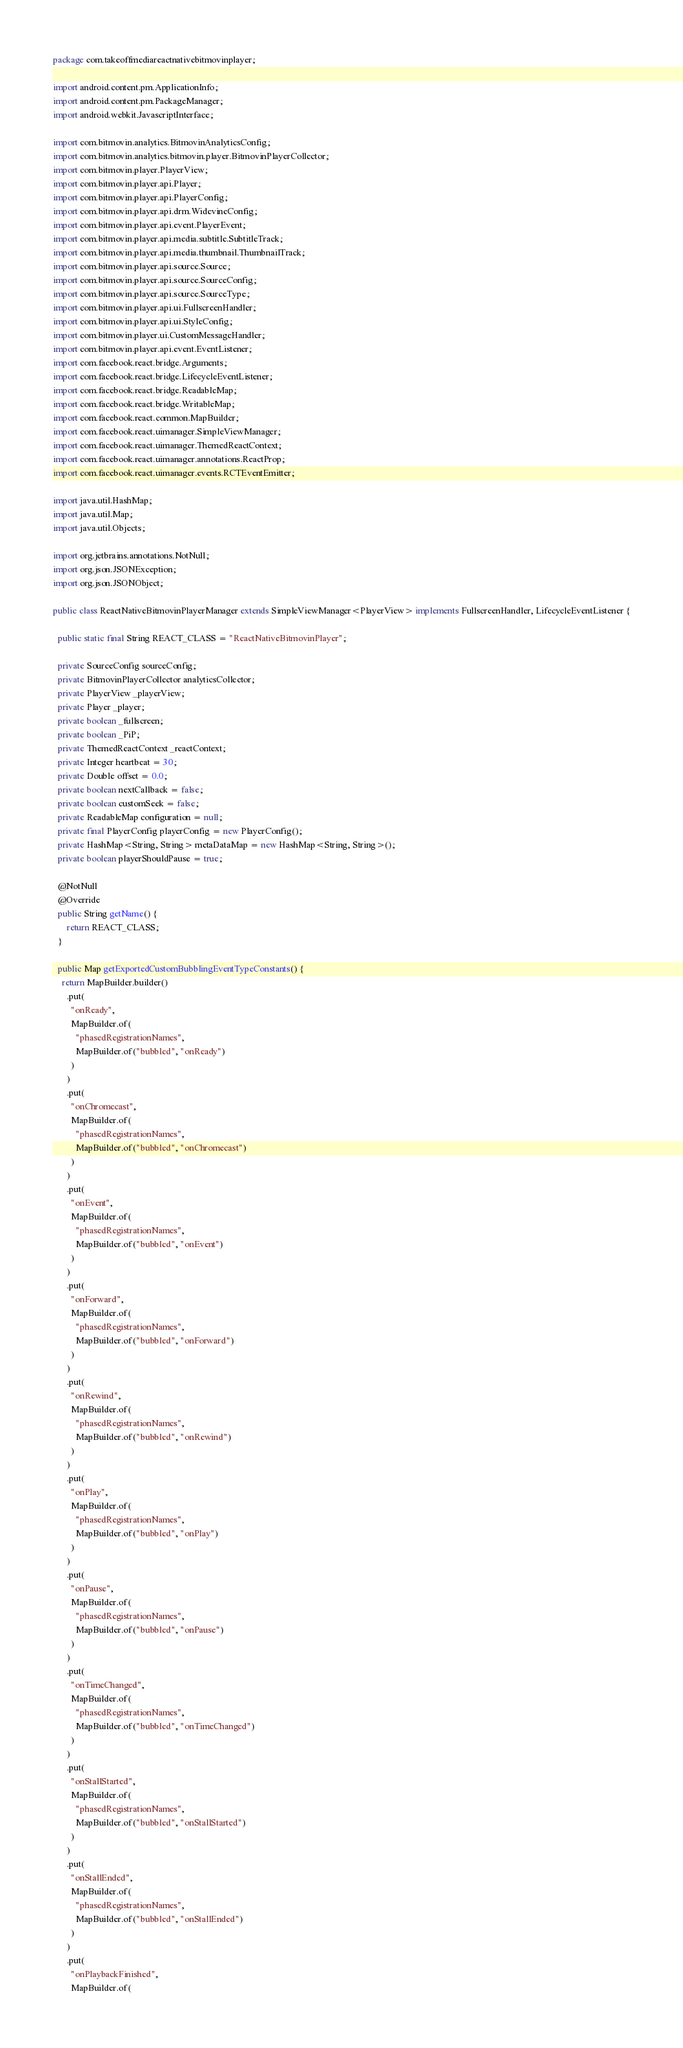Convert code to text. <code><loc_0><loc_0><loc_500><loc_500><_Java_>package com.takeoffmediareactnativebitmovinplayer;

import android.content.pm.ApplicationInfo;
import android.content.pm.PackageManager;
import android.webkit.JavascriptInterface;

import com.bitmovin.analytics.BitmovinAnalyticsConfig;
import com.bitmovin.analytics.bitmovin.player.BitmovinPlayerCollector;
import com.bitmovin.player.PlayerView;
import com.bitmovin.player.api.Player;
import com.bitmovin.player.api.PlayerConfig;
import com.bitmovin.player.api.drm.WidevineConfig;
import com.bitmovin.player.api.event.PlayerEvent;
import com.bitmovin.player.api.media.subtitle.SubtitleTrack;
import com.bitmovin.player.api.media.thumbnail.ThumbnailTrack;
import com.bitmovin.player.api.source.Source;
import com.bitmovin.player.api.source.SourceConfig;
import com.bitmovin.player.api.source.SourceType;
import com.bitmovin.player.api.ui.FullscreenHandler;
import com.bitmovin.player.api.ui.StyleConfig;
import com.bitmovin.player.ui.CustomMessageHandler;
import com.bitmovin.player.api.event.EventListener;
import com.facebook.react.bridge.Arguments;
import com.facebook.react.bridge.LifecycleEventListener;
import com.facebook.react.bridge.ReadableMap;
import com.facebook.react.bridge.WritableMap;
import com.facebook.react.common.MapBuilder;
import com.facebook.react.uimanager.SimpleViewManager;
import com.facebook.react.uimanager.ThemedReactContext;
import com.facebook.react.uimanager.annotations.ReactProp;
import com.facebook.react.uimanager.events.RCTEventEmitter;

import java.util.HashMap;
import java.util.Map;
import java.util.Objects;

import org.jetbrains.annotations.NotNull;
import org.json.JSONException;
import org.json.JSONObject;

public class ReactNativeBitmovinPlayerManager extends SimpleViewManager<PlayerView> implements FullscreenHandler, LifecycleEventListener {

  public static final String REACT_CLASS = "ReactNativeBitmovinPlayer";

  private SourceConfig sourceConfig;
  private BitmovinPlayerCollector analyticsCollector;
  private PlayerView _playerView;
  private Player _player;
  private boolean _fullscreen;
  private boolean _PiP;
  private ThemedReactContext _reactContext;
  private Integer heartbeat = 30;
  private Double offset = 0.0;
  private boolean nextCallback = false;
  private boolean customSeek = false;
  private ReadableMap configuration = null;
  private final PlayerConfig playerConfig = new PlayerConfig();
  private HashMap<String, String> metaDataMap = new HashMap<String, String>();
  private boolean playerShouldPause = true;

  @NotNull
  @Override
  public String getName() {
      return REACT_CLASS;
  }

  public Map getExportedCustomBubblingEventTypeConstants() {
    return MapBuilder.builder()
      .put(
        "onReady",
        MapBuilder.of(
          "phasedRegistrationNames",
          MapBuilder.of("bubbled", "onReady")
        )
      )
      .put(
        "onChromecast",
        MapBuilder.of(
          "phasedRegistrationNames",
          MapBuilder.of("bubbled", "onChromecast")
        )
      )
      .put(
        "onEvent",
        MapBuilder.of(
          "phasedRegistrationNames",
          MapBuilder.of("bubbled", "onEvent")
        )
      )
      .put(
        "onForward",
        MapBuilder.of(
          "phasedRegistrationNames",
          MapBuilder.of("bubbled", "onForward")
        )
      )
      .put(
        "onRewind",
        MapBuilder.of(
          "phasedRegistrationNames",
          MapBuilder.of("bubbled", "onRewind")
        )
      )
      .put(
        "onPlay",
        MapBuilder.of(
          "phasedRegistrationNames",
          MapBuilder.of("bubbled", "onPlay")
        )
      )
      .put(
        "onPause",
        MapBuilder.of(
          "phasedRegistrationNames",
          MapBuilder.of("bubbled", "onPause")
        )
      )
      .put(
        "onTimeChanged",
        MapBuilder.of(
          "phasedRegistrationNames",
          MapBuilder.of("bubbled", "onTimeChanged")
        )
      )
      .put(
        "onStallStarted",
        MapBuilder.of(
          "phasedRegistrationNames",
          MapBuilder.of("bubbled", "onStallStarted")
        )
      )
      .put(
        "onStallEnded",
        MapBuilder.of(
          "phasedRegistrationNames",
          MapBuilder.of("bubbled", "onStallEnded")
        )
      )
      .put(
        "onPlaybackFinished",
        MapBuilder.of(</code> 